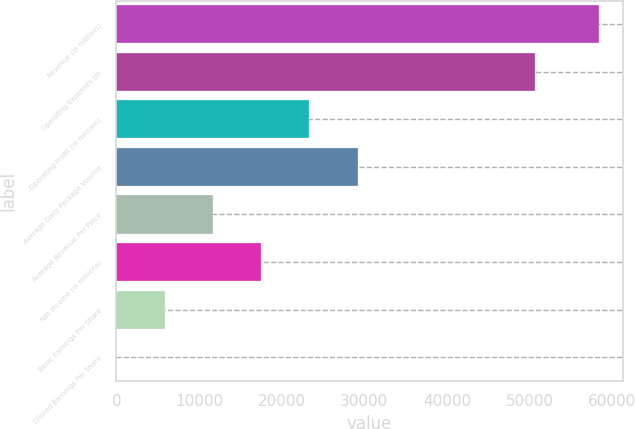<chart> <loc_0><loc_0><loc_500><loc_500><bar_chart><fcel>Revenue (in millions)<fcel>Operating Expenses (in<fcel>Operating Profit (in millions)<fcel>Average Daily Package Volume<fcel>Average Revenue Per Piece<fcel>Net Income (in millions)<fcel>Basic Earnings Per Share<fcel>Diluted Earnings Per Share<nl><fcel>58363<fcel>50695<fcel>23348.4<fcel>29184.2<fcel>11676.9<fcel>17512.7<fcel>5841.12<fcel>5.35<nl></chart> 